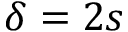Convert formula to latex. <formula><loc_0><loc_0><loc_500><loc_500>\delta = 2 s</formula> 